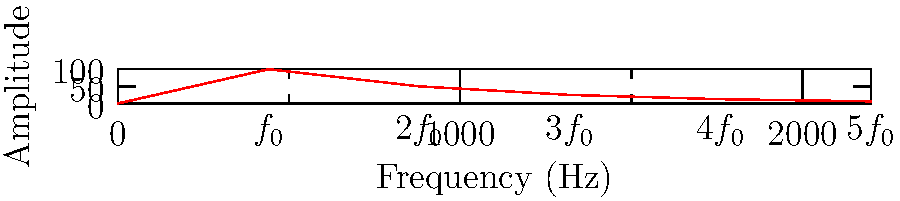In a film score, you've composed a musical note with a fundamental frequency of 440 Hz. The spectral graph of this note is shown above. Using Fourier analysis, express this note as a trigonometric series. What is the coefficient of the third harmonic in this series? To solve this problem, let's follow these steps:

1) The graph shows the amplitude spectrum of a periodic signal. The peaks represent the harmonics of the fundamental frequency $f_0 = 440$ Hz.

2) The general form of a Fourier series for a periodic signal is:

   $$f(t) = A_0 + \sum_{n=1}^{\infty} A_n \cos(2\pi n f_0 t + \phi_n)$$

   where $A_0$ is the DC component (which is 0 in this case), $A_n$ is the amplitude of the nth harmonic, and $\phi_n$ is the phase of the nth harmonic.

3) From the graph, we can read the amplitudes of the harmonics:
   - 1st harmonic (fundamental): 100
   - 2nd harmonic: 50
   - 3rd harmonic: 25
   - 4th harmonic: 12.5
   - 5th harmonic: 6.25

4) The coefficient $A_n$ in the Fourier series is related to the amplitude in the spectrum by a factor of 2. This is because the energy is split between positive and negative frequencies in the complex Fourier transform.

5) Therefore, the coefficient of the third harmonic is:

   $A_3 = 25/2 = 12.5$

6) The complete trigonometric series (ignoring phase for simplicity) would be:

   $$f(t) = 50\cos(2\pi 440t) + 25\cos(2\pi 880t) + 12.5\cos(2\pi 1320t) + 6.25\cos(2\pi 1760t) + 3.125\cos(2\pi 2200t) + ...$$
Answer: 12.5 